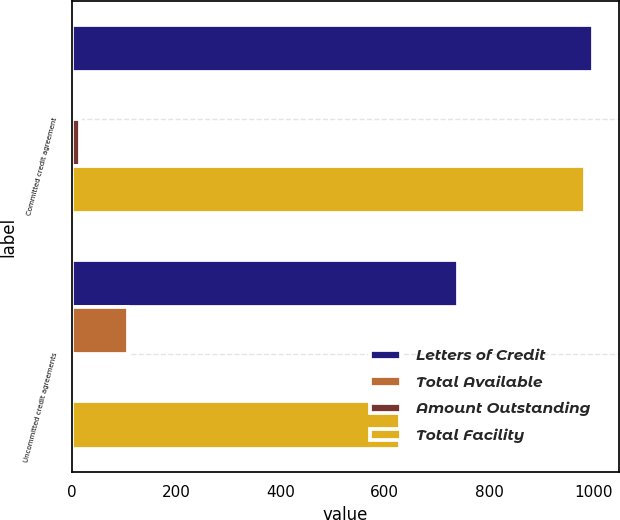<chart> <loc_0><loc_0><loc_500><loc_500><stacked_bar_chart><ecel><fcel>Committed credit agreement<fcel>Uncommitted credit agreements<nl><fcel>Letters of Credit<fcel>1000<fcel>740.3<nl><fcel>Total Available<fcel>0<fcel>107.2<nl><fcel>Amount Outstanding<fcel>16<fcel>3.9<nl><fcel>Total Facility<fcel>984<fcel>629.2<nl></chart> 